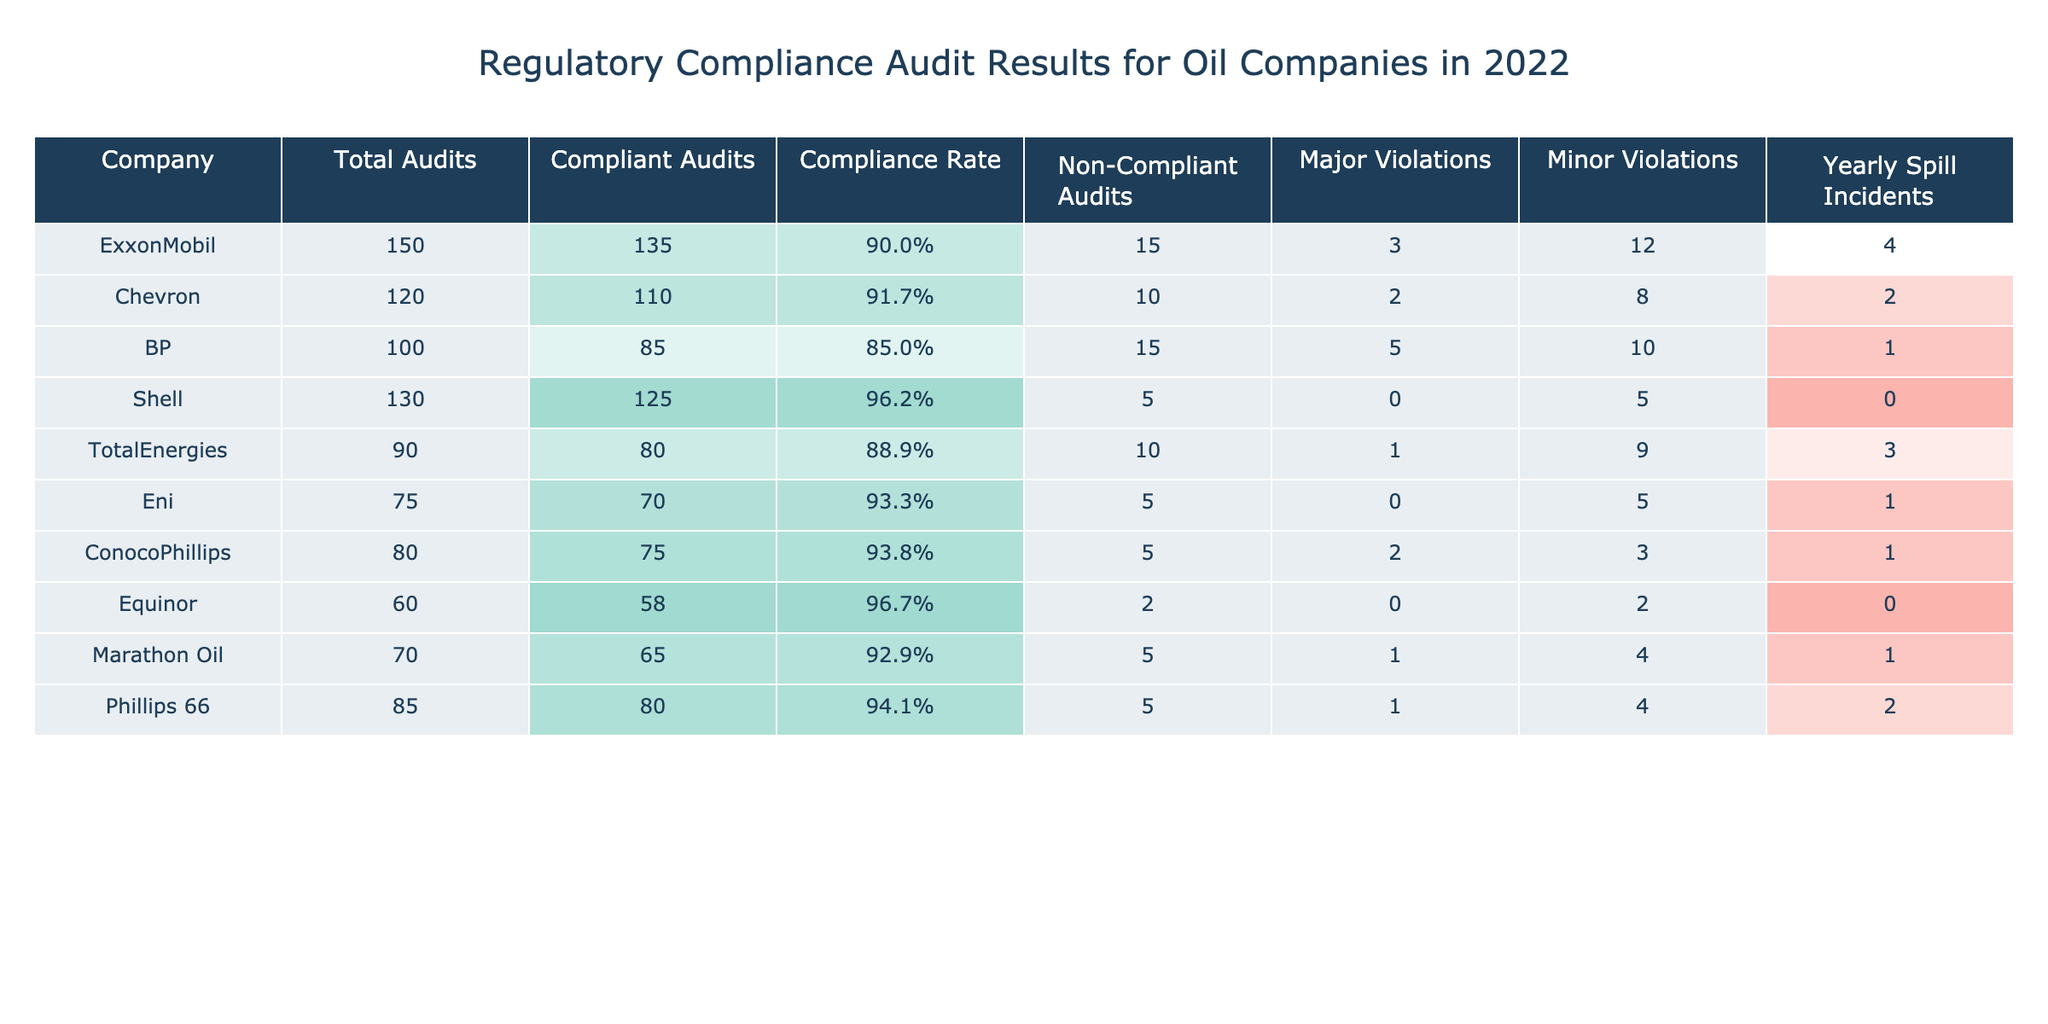What is the compliance rate of Chevron? The compliance rate for Chevron is calculated by dividing the number of compliant audits (110) by the total audits (120) and multiplying by 100, resulting in (110/120) * 100 = 91.7%.
Answer: 91.7% Which company had the highest number of major violations? BP had the highest number of major violations with a total of 5 violations.
Answer: BP How many non-compliant audits did Shell have? Shell had 5 non-compliant audits listed in the table.
Answer: 5 What is the total number of audits conducted by all companies in 2022? The total number of audits can be found by summing the total audits of each company. (150 + 120 + 100 + 130 + 90 + 75 + 80 + 60 + 70 + 85) = 1,060.
Answer: 1,060 Which company had the lowest number of yearly spill incidents? Shell and Equinor both had the lowest number of yearly spill incidents with 0 incidents each.
Answer: Shell and Equinor What is the average compliance rate of all companies? The compliance rates of all companies must be calculated individually first, then averaged: (90, 91.7, 85, 96.2, 88.9, 93.3, 93.8, 96.7, 92.9) / 9 = 91.7%.
Answer: 91.7% Which company had the lowest compliance rate? BP had the lowest compliance rate, which is calculated as (85/100) * 100 = 85%.
Answer: BP Is it true that Eni had more minor violations than major violations? Eni had 5 minor violations and 0 major violations, confirming that there are more minor violations than major.
Answer: Yes What is the difference in yearly spill incidents between ExxonMobil and TotalEnergies? ExxonMobil had 4 yearly spill incidents, while TotalEnergies had 3. The difference is 4 - 3 = 1.
Answer: 1 How many companies had more than 10 total audits? The companies that had more than 10 total audits are ExxonMobil (150), Chevron (120), BP (100), Shell (130), TotalEnergies (90), Phillips 66 (85), and ConocoPhillips (80), totaling 7 companies.
Answer: 7 Which company had the highest compliance rate while also having the fewest yearly spill incidents? Shell had the highest compliance rate of 96.2% and the fewest spill incidents totaling 0, making it the company that satisfies both conditions.
Answer: Shell 